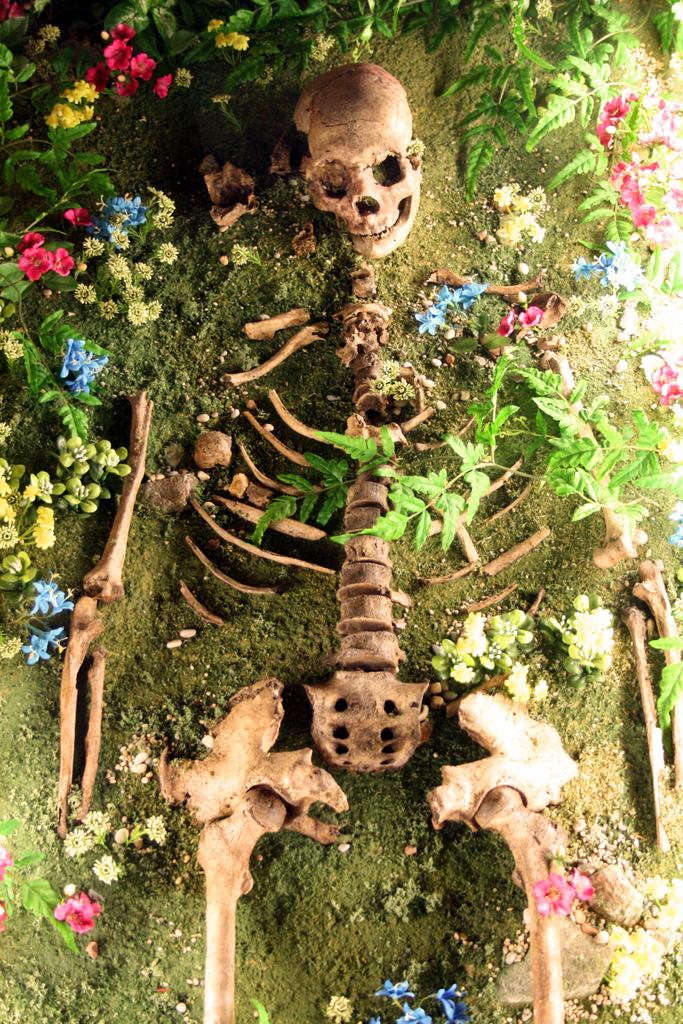What is the main subject of the image? There is a skeleton in the image. What can be seen in the background of the image? There is mud and plants in the background of the image. Are there any other objects or elements in the image besides the skeleton? Yes, there are flowers in the image. How many bears can be seen interacting with the flowers in the image? There are no bears present in the image; it features a skeleton and flowers. What type of test is being conducted in the image? There is no test being conducted in the image; it shows a skeleton, mud, plants, and flowers. 